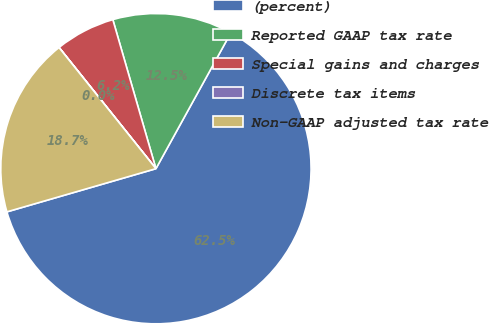Convert chart to OTSL. <chart><loc_0><loc_0><loc_500><loc_500><pie_chart><fcel>(percent)<fcel>Reported GAAP tax rate<fcel>Special gains and charges<fcel>Discrete tax items<fcel>Non-GAAP adjusted tax rate<nl><fcel>62.49%<fcel>12.5%<fcel>6.25%<fcel>0.01%<fcel>18.75%<nl></chart> 